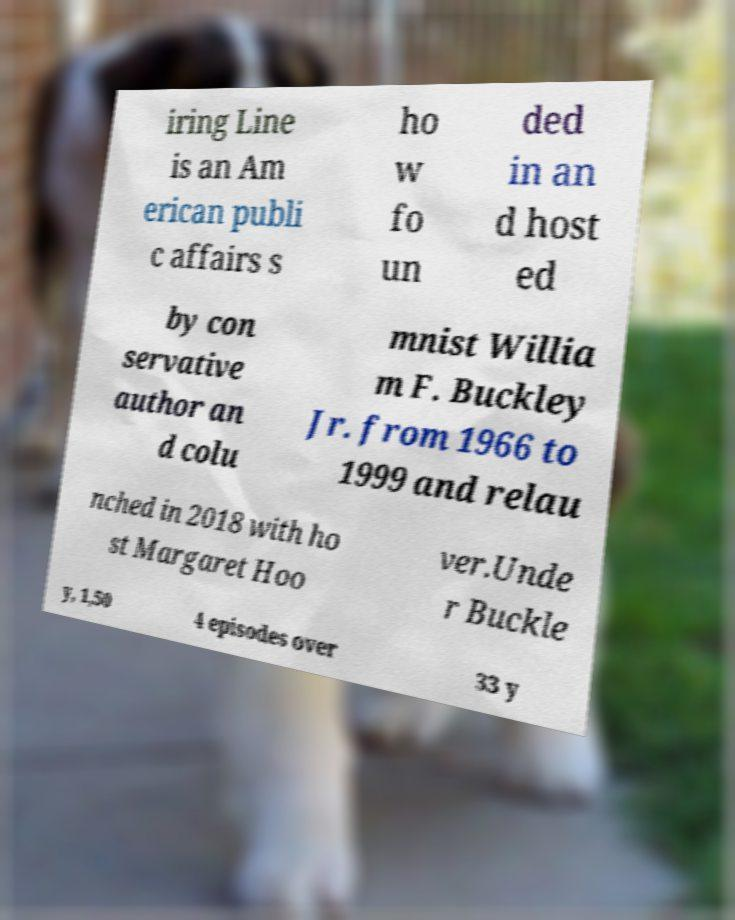What messages or text are displayed in this image? I need them in a readable, typed format. iring Line is an Am erican publi c affairs s ho w fo un ded in an d host ed by con servative author an d colu mnist Willia m F. Buckley Jr. from 1966 to 1999 and relau nched in 2018 with ho st Margaret Hoo ver.Unde r Buckle y, 1,50 4 episodes over 33 y 